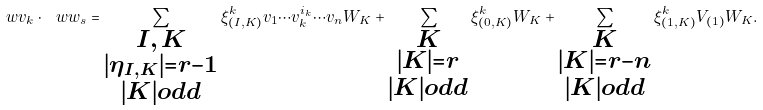<formula> <loc_0><loc_0><loc_500><loc_500>\ w v _ { k } \cdot \ w w _ { s } = \sum _ { \substack { { I , \, K } \\ { | \eta _ { I , K } | = r - 1 } \\ | K | o d d } } \xi ^ { k } _ { ( I , K ) } v _ { 1 } \cdots v _ { k } ^ { i _ { k } } \cdots v _ { n } W _ { K } + \sum _ { \substack { { K } \\ { | K | = r } \\ | K | o d d } } \xi ^ { k } _ { ( 0 , K ) } W _ { K } + \sum _ { \substack { { K } \\ { | K | = r - n } \\ | K | o d d } } \xi ^ { k } _ { ( 1 , K ) } V _ { ( 1 ) } W _ { K } .</formula> 